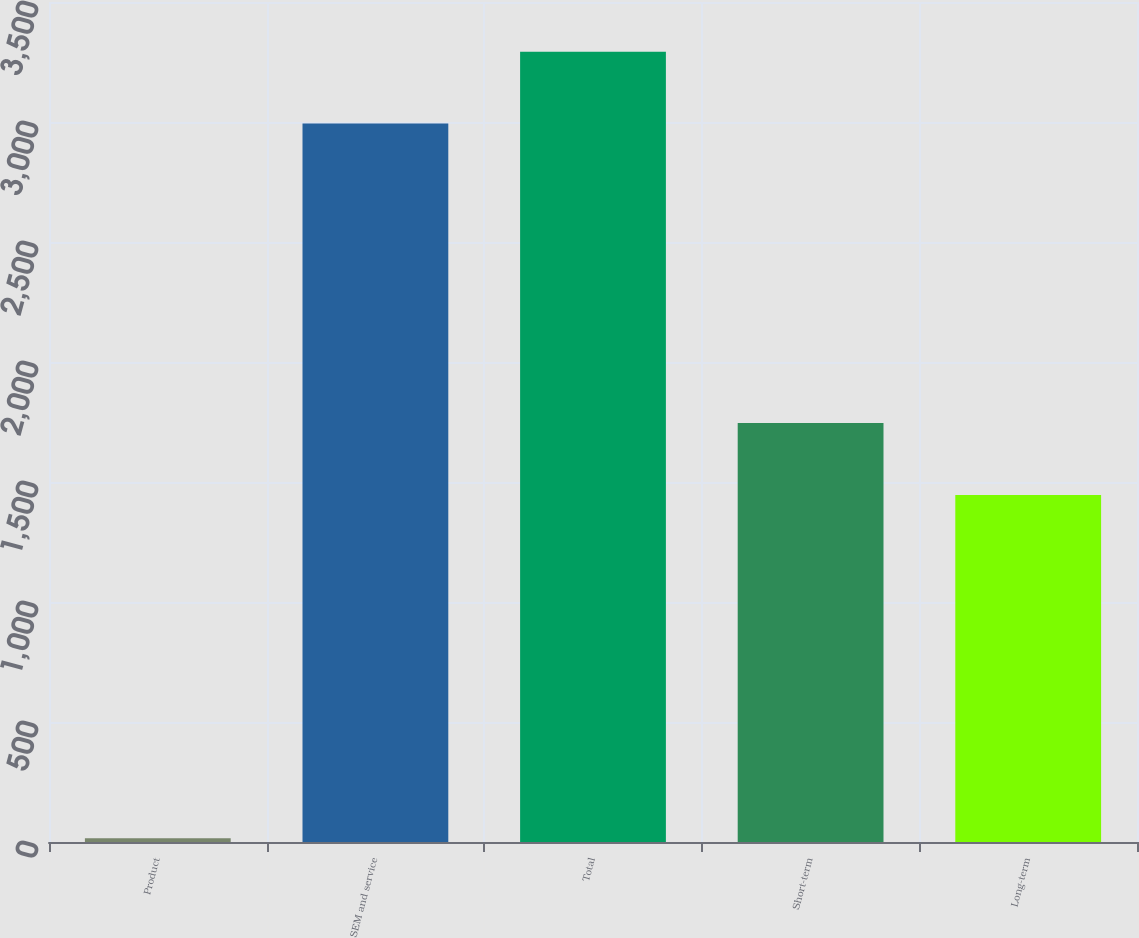Convert chart. <chart><loc_0><loc_0><loc_500><loc_500><bar_chart><fcel>Product<fcel>SEM and service<fcel>Total<fcel>Short-term<fcel>Long-term<nl><fcel>15.7<fcel>2993.8<fcel>3293.18<fcel>1745.58<fcel>1446.2<nl></chart> 